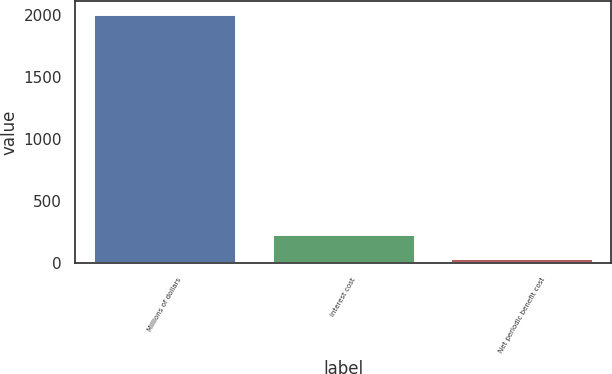Convert chart to OTSL. <chart><loc_0><loc_0><loc_500><loc_500><bar_chart><fcel>Millions of dollars<fcel>Interest cost<fcel>Net periodic benefit cost<nl><fcel>2007<fcel>236.7<fcel>40<nl></chart> 